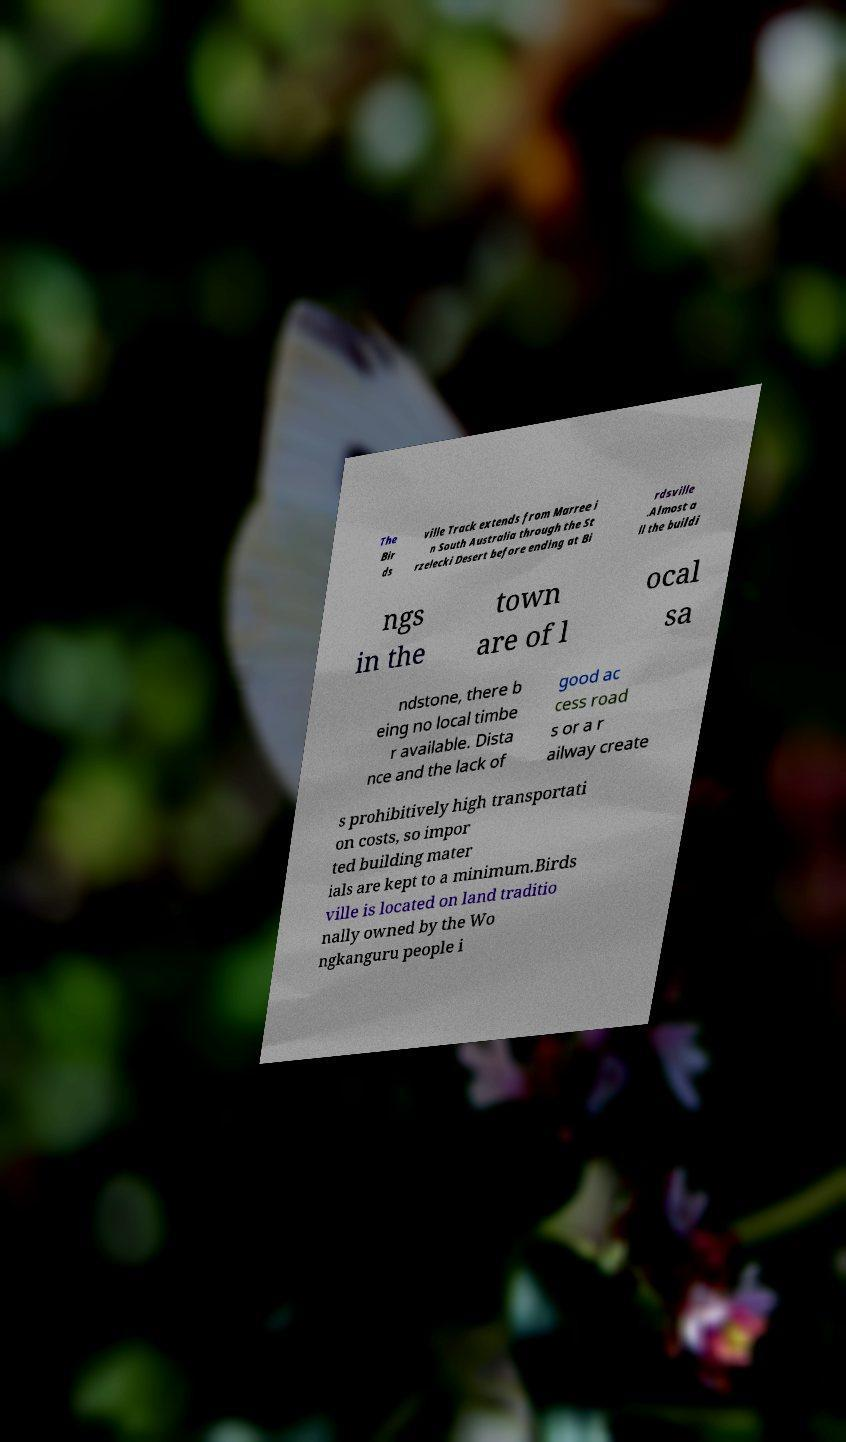I need the written content from this picture converted into text. Can you do that? The Bir ds ville Track extends from Marree i n South Australia through the St rzelecki Desert before ending at Bi rdsville .Almost a ll the buildi ngs in the town are of l ocal sa ndstone, there b eing no local timbe r available. Dista nce and the lack of good ac cess road s or a r ailway create s prohibitively high transportati on costs, so impor ted building mater ials are kept to a minimum.Birds ville is located on land traditio nally owned by the Wo ngkanguru people i 